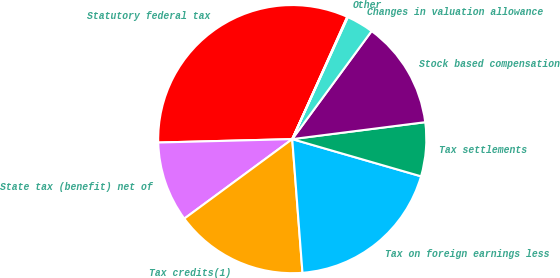Convert chart to OTSL. <chart><loc_0><loc_0><loc_500><loc_500><pie_chart><fcel>Statutory federal tax<fcel>State tax (benefit) net of<fcel>Tax credits(1)<fcel>Tax on foreign earnings less<fcel>Tax settlements<fcel>Stock based compensation<fcel>Changes in valuation allowance<fcel>Other<nl><fcel>32.13%<fcel>9.7%<fcel>16.11%<fcel>19.31%<fcel>6.49%<fcel>12.9%<fcel>3.28%<fcel>0.08%<nl></chart> 